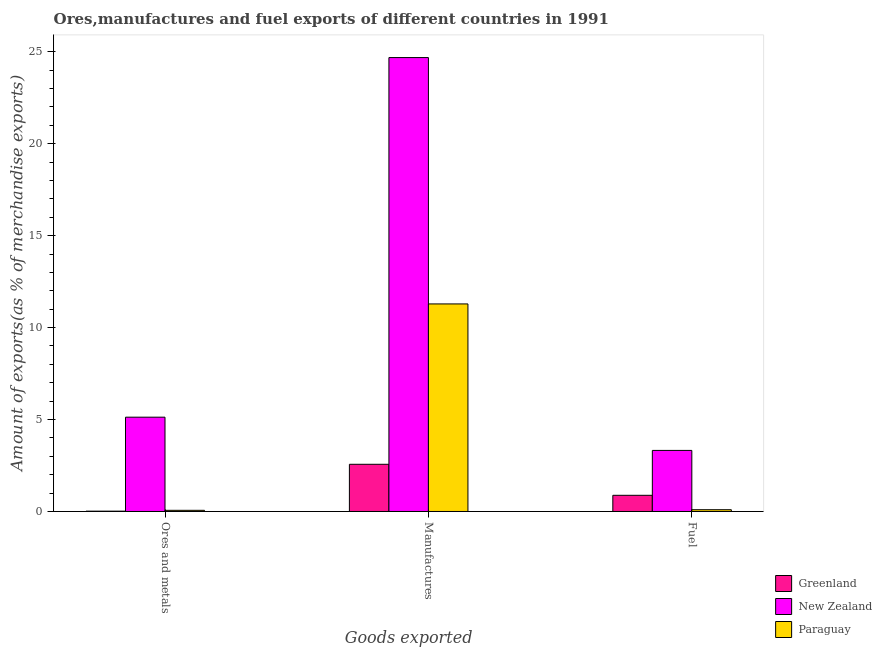How many different coloured bars are there?
Make the answer very short. 3. How many bars are there on the 3rd tick from the right?
Keep it short and to the point. 3. What is the label of the 3rd group of bars from the left?
Make the answer very short. Fuel. What is the percentage of ores and metals exports in Paraguay?
Ensure brevity in your answer.  0.06. Across all countries, what is the maximum percentage of ores and metals exports?
Your response must be concise. 5.13. Across all countries, what is the minimum percentage of manufactures exports?
Keep it short and to the point. 2.57. In which country was the percentage of manufactures exports maximum?
Offer a very short reply. New Zealand. In which country was the percentage of ores and metals exports minimum?
Your answer should be compact. Greenland. What is the total percentage of ores and metals exports in the graph?
Your response must be concise. 5.21. What is the difference between the percentage of fuel exports in Paraguay and that in New Zealand?
Keep it short and to the point. -3.22. What is the difference between the percentage of manufactures exports in Greenland and the percentage of fuel exports in New Zealand?
Make the answer very short. -0.75. What is the average percentage of ores and metals exports per country?
Ensure brevity in your answer.  1.74. What is the difference between the percentage of manufactures exports and percentage of ores and metals exports in Paraguay?
Your response must be concise. 11.22. What is the ratio of the percentage of manufactures exports in New Zealand to that in Greenland?
Keep it short and to the point. 9.62. Is the difference between the percentage of fuel exports in Paraguay and Greenland greater than the difference between the percentage of manufactures exports in Paraguay and Greenland?
Keep it short and to the point. No. What is the difference between the highest and the second highest percentage of ores and metals exports?
Give a very brief answer. 5.06. What is the difference between the highest and the lowest percentage of ores and metals exports?
Your response must be concise. 5.11. In how many countries, is the percentage of manufactures exports greater than the average percentage of manufactures exports taken over all countries?
Give a very brief answer. 1. Is the sum of the percentage of ores and metals exports in New Zealand and Paraguay greater than the maximum percentage of manufactures exports across all countries?
Your answer should be compact. No. What does the 1st bar from the left in Fuel represents?
Your response must be concise. Greenland. What does the 2nd bar from the right in Manufactures represents?
Give a very brief answer. New Zealand. Is it the case that in every country, the sum of the percentage of ores and metals exports and percentage of manufactures exports is greater than the percentage of fuel exports?
Give a very brief answer. Yes. How many countries are there in the graph?
Offer a very short reply. 3. What is the difference between two consecutive major ticks on the Y-axis?
Offer a terse response. 5. Does the graph contain grids?
Offer a very short reply. No. How many legend labels are there?
Your answer should be very brief. 3. What is the title of the graph?
Offer a terse response. Ores,manufactures and fuel exports of different countries in 1991. What is the label or title of the X-axis?
Provide a short and direct response. Goods exported. What is the label or title of the Y-axis?
Offer a very short reply. Amount of exports(as % of merchandise exports). What is the Amount of exports(as % of merchandise exports) of Greenland in Ores and metals?
Provide a short and direct response. 0.02. What is the Amount of exports(as % of merchandise exports) of New Zealand in Ores and metals?
Offer a terse response. 5.13. What is the Amount of exports(as % of merchandise exports) in Paraguay in Ores and metals?
Ensure brevity in your answer.  0.06. What is the Amount of exports(as % of merchandise exports) of Greenland in Manufactures?
Make the answer very short. 2.57. What is the Amount of exports(as % of merchandise exports) in New Zealand in Manufactures?
Ensure brevity in your answer.  24.68. What is the Amount of exports(as % of merchandise exports) in Paraguay in Manufactures?
Your answer should be very brief. 11.29. What is the Amount of exports(as % of merchandise exports) in Greenland in Fuel?
Keep it short and to the point. 0.88. What is the Amount of exports(as % of merchandise exports) of New Zealand in Fuel?
Provide a short and direct response. 3.32. What is the Amount of exports(as % of merchandise exports) of Paraguay in Fuel?
Ensure brevity in your answer.  0.1. Across all Goods exported, what is the maximum Amount of exports(as % of merchandise exports) of Greenland?
Offer a terse response. 2.57. Across all Goods exported, what is the maximum Amount of exports(as % of merchandise exports) in New Zealand?
Give a very brief answer. 24.68. Across all Goods exported, what is the maximum Amount of exports(as % of merchandise exports) in Paraguay?
Give a very brief answer. 11.29. Across all Goods exported, what is the minimum Amount of exports(as % of merchandise exports) in Greenland?
Ensure brevity in your answer.  0.02. Across all Goods exported, what is the minimum Amount of exports(as % of merchandise exports) in New Zealand?
Ensure brevity in your answer.  3.32. Across all Goods exported, what is the minimum Amount of exports(as % of merchandise exports) in Paraguay?
Make the answer very short. 0.06. What is the total Amount of exports(as % of merchandise exports) in Greenland in the graph?
Offer a terse response. 3.46. What is the total Amount of exports(as % of merchandise exports) in New Zealand in the graph?
Give a very brief answer. 33.13. What is the total Amount of exports(as % of merchandise exports) of Paraguay in the graph?
Provide a short and direct response. 11.44. What is the difference between the Amount of exports(as % of merchandise exports) of Greenland in Ores and metals and that in Manufactures?
Offer a terse response. -2.55. What is the difference between the Amount of exports(as % of merchandise exports) of New Zealand in Ores and metals and that in Manufactures?
Offer a terse response. -19.55. What is the difference between the Amount of exports(as % of merchandise exports) of Paraguay in Ores and metals and that in Manufactures?
Provide a succinct answer. -11.22. What is the difference between the Amount of exports(as % of merchandise exports) of Greenland in Ores and metals and that in Fuel?
Ensure brevity in your answer.  -0.86. What is the difference between the Amount of exports(as % of merchandise exports) of New Zealand in Ores and metals and that in Fuel?
Offer a terse response. 1.81. What is the difference between the Amount of exports(as % of merchandise exports) of Paraguay in Ores and metals and that in Fuel?
Ensure brevity in your answer.  -0.03. What is the difference between the Amount of exports(as % of merchandise exports) of Greenland in Manufactures and that in Fuel?
Give a very brief answer. 1.69. What is the difference between the Amount of exports(as % of merchandise exports) in New Zealand in Manufactures and that in Fuel?
Give a very brief answer. 21.36. What is the difference between the Amount of exports(as % of merchandise exports) of Paraguay in Manufactures and that in Fuel?
Make the answer very short. 11.19. What is the difference between the Amount of exports(as % of merchandise exports) of Greenland in Ores and metals and the Amount of exports(as % of merchandise exports) of New Zealand in Manufactures?
Give a very brief answer. -24.66. What is the difference between the Amount of exports(as % of merchandise exports) of Greenland in Ores and metals and the Amount of exports(as % of merchandise exports) of Paraguay in Manufactures?
Provide a short and direct response. -11.27. What is the difference between the Amount of exports(as % of merchandise exports) of New Zealand in Ores and metals and the Amount of exports(as % of merchandise exports) of Paraguay in Manufactures?
Your answer should be very brief. -6.16. What is the difference between the Amount of exports(as % of merchandise exports) of Greenland in Ores and metals and the Amount of exports(as % of merchandise exports) of New Zealand in Fuel?
Provide a short and direct response. -3.3. What is the difference between the Amount of exports(as % of merchandise exports) in Greenland in Ores and metals and the Amount of exports(as % of merchandise exports) in Paraguay in Fuel?
Offer a terse response. -0.08. What is the difference between the Amount of exports(as % of merchandise exports) in New Zealand in Ores and metals and the Amount of exports(as % of merchandise exports) in Paraguay in Fuel?
Your answer should be very brief. 5.03. What is the difference between the Amount of exports(as % of merchandise exports) in Greenland in Manufactures and the Amount of exports(as % of merchandise exports) in New Zealand in Fuel?
Make the answer very short. -0.75. What is the difference between the Amount of exports(as % of merchandise exports) in Greenland in Manufactures and the Amount of exports(as % of merchandise exports) in Paraguay in Fuel?
Offer a terse response. 2.47. What is the difference between the Amount of exports(as % of merchandise exports) in New Zealand in Manufactures and the Amount of exports(as % of merchandise exports) in Paraguay in Fuel?
Keep it short and to the point. 24.58. What is the average Amount of exports(as % of merchandise exports) in Greenland per Goods exported?
Make the answer very short. 1.15. What is the average Amount of exports(as % of merchandise exports) of New Zealand per Goods exported?
Offer a very short reply. 11.04. What is the average Amount of exports(as % of merchandise exports) of Paraguay per Goods exported?
Your response must be concise. 3.81. What is the difference between the Amount of exports(as % of merchandise exports) in Greenland and Amount of exports(as % of merchandise exports) in New Zealand in Ores and metals?
Give a very brief answer. -5.11. What is the difference between the Amount of exports(as % of merchandise exports) in Greenland and Amount of exports(as % of merchandise exports) in Paraguay in Ores and metals?
Offer a very short reply. -0.05. What is the difference between the Amount of exports(as % of merchandise exports) in New Zealand and Amount of exports(as % of merchandise exports) in Paraguay in Ores and metals?
Your response must be concise. 5.06. What is the difference between the Amount of exports(as % of merchandise exports) of Greenland and Amount of exports(as % of merchandise exports) of New Zealand in Manufactures?
Offer a very short reply. -22.11. What is the difference between the Amount of exports(as % of merchandise exports) of Greenland and Amount of exports(as % of merchandise exports) of Paraguay in Manufactures?
Provide a succinct answer. -8.72. What is the difference between the Amount of exports(as % of merchandise exports) of New Zealand and Amount of exports(as % of merchandise exports) of Paraguay in Manufactures?
Offer a terse response. 13.4. What is the difference between the Amount of exports(as % of merchandise exports) in Greenland and Amount of exports(as % of merchandise exports) in New Zealand in Fuel?
Your answer should be compact. -2.44. What is the difference between the Amount of exports(as % of merchandise exports) of Greenland and Amount of exports(as % of merchandise exports) of Paraguay in Fuel?
Make the answer very short. 0.78. What is the difference between the Amount of exports(as % of merchandise exports) in New Zealand and Amount of exports(as % of merchandise exports) in Paraguay in Fuel?
Provide a short and direct response. 3.22. What is the ratio of the Amount of exports(as % of merchandise exports) of Greenland in Ores and metals to that in Manufactures?
Give a very brief answer. 0.01. What is the ratio of the Amount of exports(as % of merchandise exports) of New Zealand in Ores and metals to that in Manufactures?
Provide a succinct answer. 0.21. What is the ratio of the Amount of exports(as % of merchandise exports) in Paraguay in Ores and metals to that in Manufactures?
Offer a very short reply. 0.01. What is the ratio of the Amount of exports(as % of merchandise exports) of Greenland in Ores and metals to that in Fuel?
Your answer should be very brief. 0.02. What is the ratio of the Amount of exports(as % of merchandise exports) in New Zealand in Ores and metals to that in Fuel?
Keep it short and to the point. 1.54. What is the ratio of the Amount of exports(as % of merchandise exports) in Paraguay in Ores and metals to that in Fuel?
Ensure brevity in your answer.  0.66. What is the ratio of the Amount of exports(as % of merchandise exports) in Greenland in Manufactures to that in Fuel?
Your answer should be compact. 2.92. What is the ratio of the Amount of exports(as % of merchandise exports) of New Zealand in Manufactures to that in Fuel?
Keep it short and to the point. 7.43. What is the ratio of the Amount of exports(as % of merchandise exports) of Paraguay in Manufactures to that in Fuel?
Provide a short and direct response. 117.57. What is the difference between the highest and the second highest Amount of exports(as % of merchandise exports) in Greenland?
Keep it short and to the point. 1.69. What is the difference between the highest and the second highest Amount of exports(as % of merchandise exports) in New Zealand?
Give a very brief answer. 19.55. What is the difference between the highest and the second highest Amount of exports(as % of merchandise exports) in Paraguay?
Ensure brevity in your answer.  11.19. What is the difference between the highest and the lowest Amount of exports(as % of merchandise exports) of Greenland?
Your answer should be compact. 2.55. What is the difference between the highest and the lowest Amount of exports(as % of merchandise exports) in New Zealand?
Offer a very short reply. 21.36. What is the difference between the highest and the lowest Amount of exports(as % of merchandise exports) in Paraguay?
Make the answer very short. 11.22. 